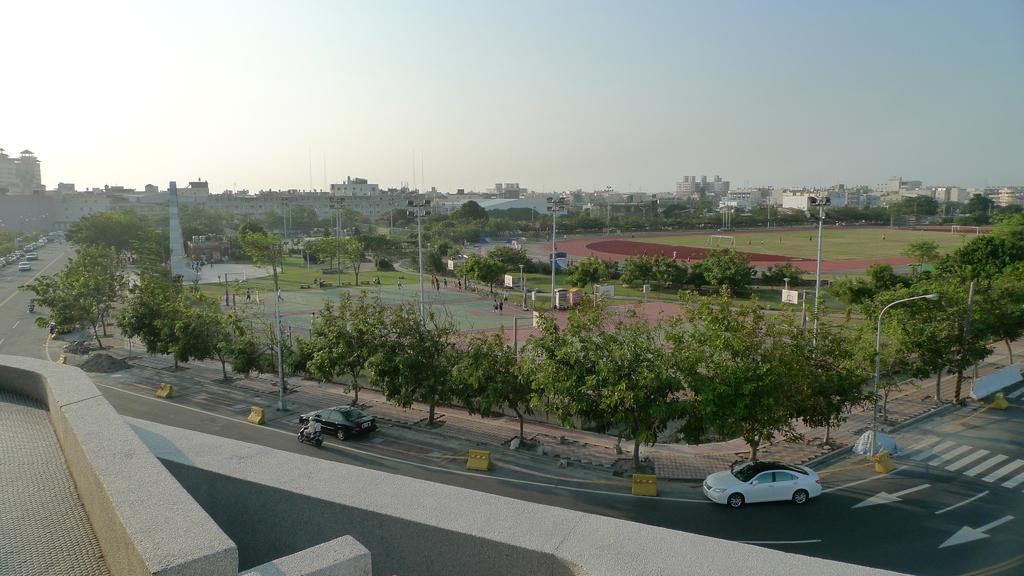Could you give a brief overview of what you see in this image? In the image we can see there are many vehicles on the road. This is a road, light pole, trees, footpath, buildings, ground and a pale blue sky. We can see there are even people wearing clothes. This is a barrier. 